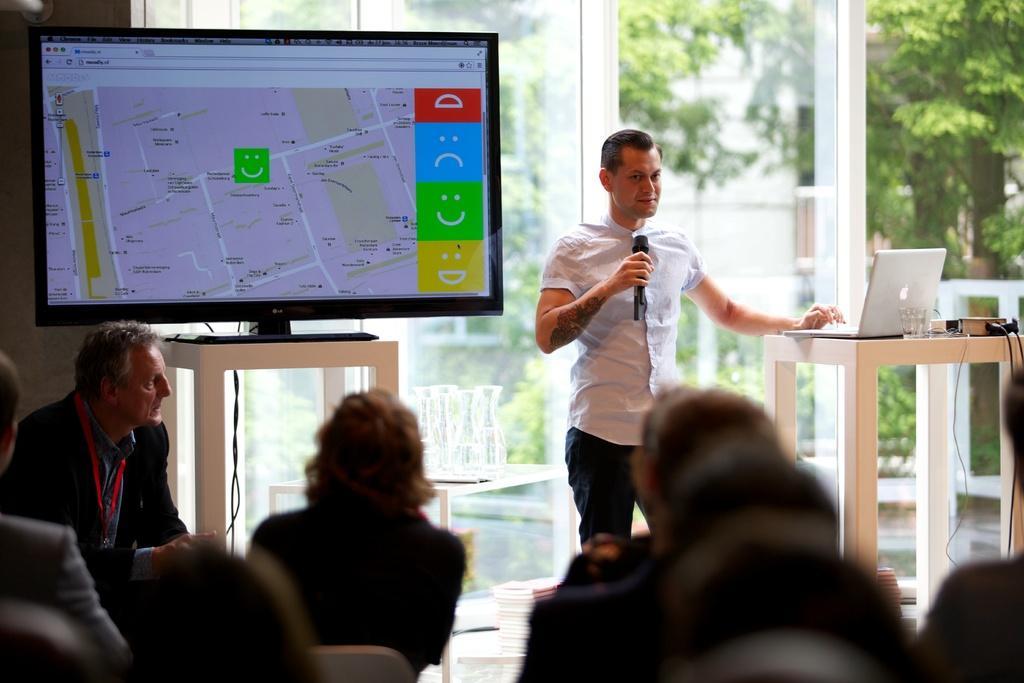Please provide a concise description of this image. In this picture there are people sitting on chair and there is a man standing and holding a microphone. We can see laptop, glass, device and television on tables. In the background of the image we can see glass, through glass we can see trees, objects on the table and plants. 